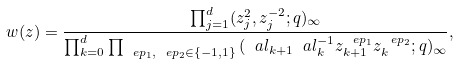<formula> <loc_0><loc_0><loc_500><loc_500>w ( z ) = \frac { \prod _ { j = 1 } ^ { d } ( z _ { j } ^ { 2 } , z _ { j } ^ { - 2 } ; q ) _ { \infty } } { \prod _ { k = 0 } ^ { d } \prod _ { \ e p _ { 1 } , \ e p _ { 2 } \in \{ - 1 , 1 \} } \, ( \ a l _ { k + 1 } \ a l _ { k } ^ { - 1 } z _ { k + 1 } ^ { \ e p _ { 1 } } z _ { k } ^ { \ e p _ { 2 } } ; q ) _ { \infty } } ,</formula> 